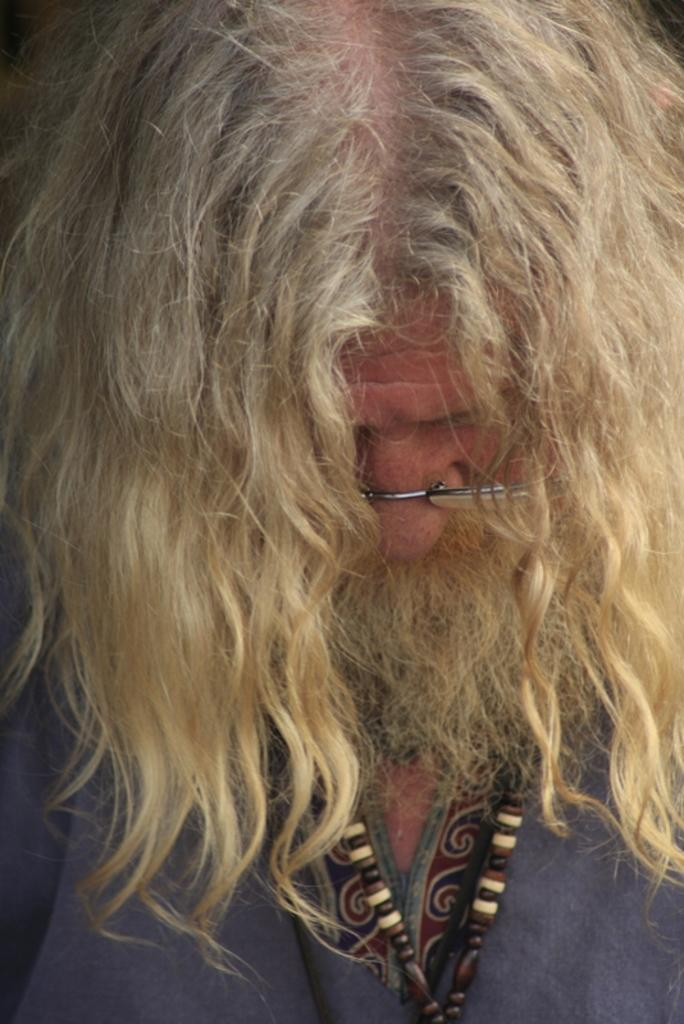What is the appearance of the man in the image? The man has blonde hair and is wearing spectacles. What is the man wearing in the image? The man is wearing a grey color dress. Can you describe any other features of the man in the image? The man has blonde hair and is wearing spectacles. What else can be seen in the image besides the man? There is an unspecified object in the image. What type of badge is the man wearing in the image? There is no mention of a badge in the image, so it cannot be determined if the man is wearing one. How does the man's nerve affect his actions in the image? There is no information about the man's nerve or its effect on his actions in the image. 